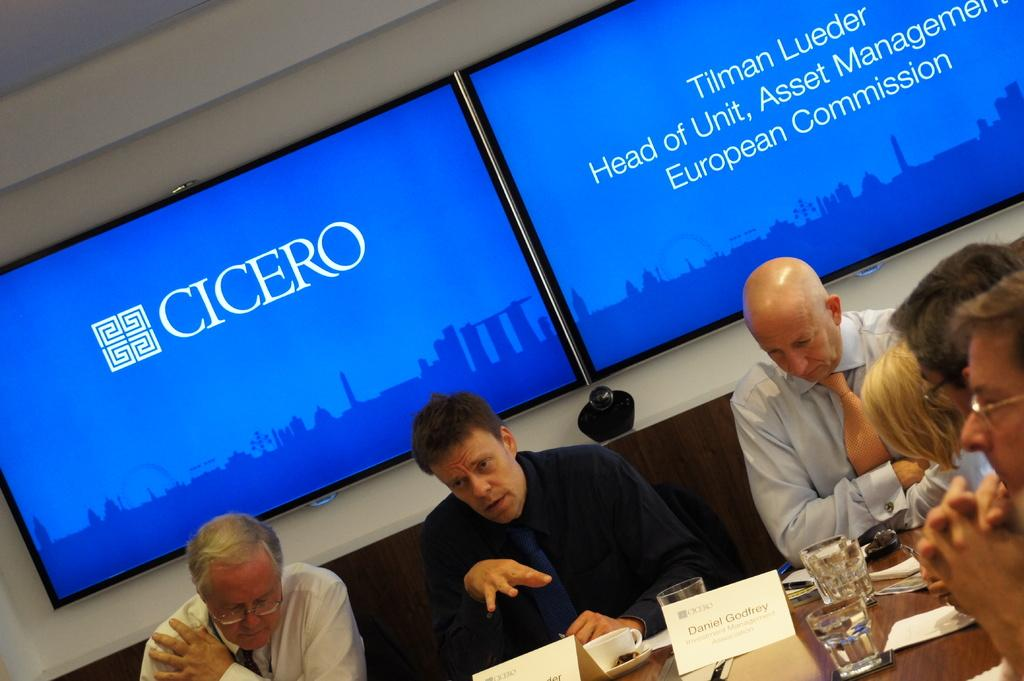Who or what can be seen in the image? There are people in the image. What else is present in the image besides the people? There are objects on a table and televisions on the wall in the image. What is displayed on the televisions? There is text visible on the screen of the televisions, and there are animated objects on the screen as well. What type of faucet can be seen in the image? There is no faucet present in the image. How does the taste of the objects on the table compare to the taste of the animated objects on the screen of the televisions? There is no information about the taste of any objects in the image, as it only mentions the presence of people, objects on a table, televisions, and the content displayed on the screens. 